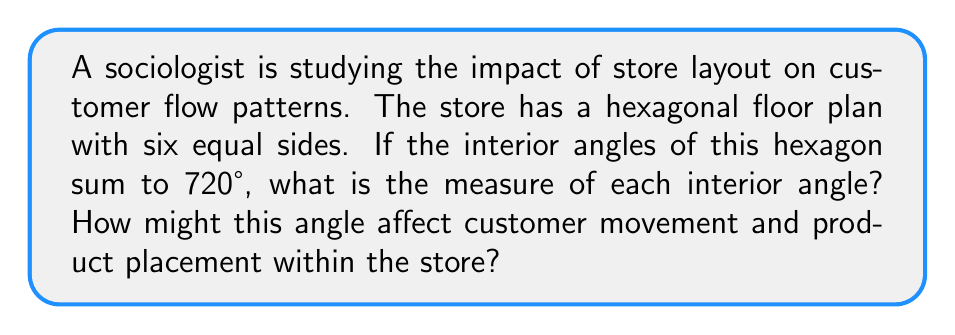Provide a solution to this math problem. To solve this problem, we'll use principles of geometry and then relate it to sociological concepts:

1) First, let's recall the formula for the sum of interior angles of a polygon:
   $$(n - 2) \times 180°$$
   where $n$ is the number of sides.

2) We're given that the sum of interior angles is 720°, so:
   $$(n - 2) \times 180° = 720°$$

3) We know it's a hexagon, so $n = 6$. Let's verify:
   $$(6 - 2) \times 180° = 4 \times 180° = 720°$$
   This confirms our information.

4) To find each interior angle, we divide the total by the number of angles:
   $$\frac{720°}{6} = 120°$$

5) Sociological interpretation:
   - A 120° angle is wider than a right angle (90°), creating more open spaces.
   - This could lead to:
     a) Easier customer flow and less congestion
     b) More visibility across the store
     c) Potential for larger product displays at corners
   - However, it might also result in:
     a) Less defined sections within the store
     b) Customers potentially missing products in corner areas

6) The layout could influence consumer behavior by:
   - Encouraging exploration due to open sight lines
   - Potentially increasing impulse purchases due to better visibility
   - Affecting the time spent in the store due to ease of movement

Understanding these impacts can help sociologists study how store design influences consumer choices and social interactions within retail spaces.
Answer: Each interior angle of the hexagonal store layout measures 120°. This angle creates a relatively open floor plan that could facilitate easier customer movement and broader product visibility, potentially influencing consumer behavior and purchasing decisions. 